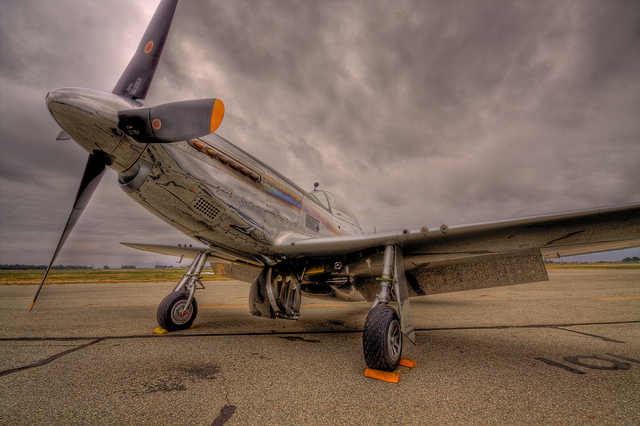<image>What type of plane is this? I don't know what type of plane this is, there are varying answers of it being a propeller plane or a jet plane amongst others. What type of plane is this? I am not sure what type of plane it is. It can be seen as an older one, a prop, a propeller plane, a private plane, a jet plane, or a single engine propeller plane 